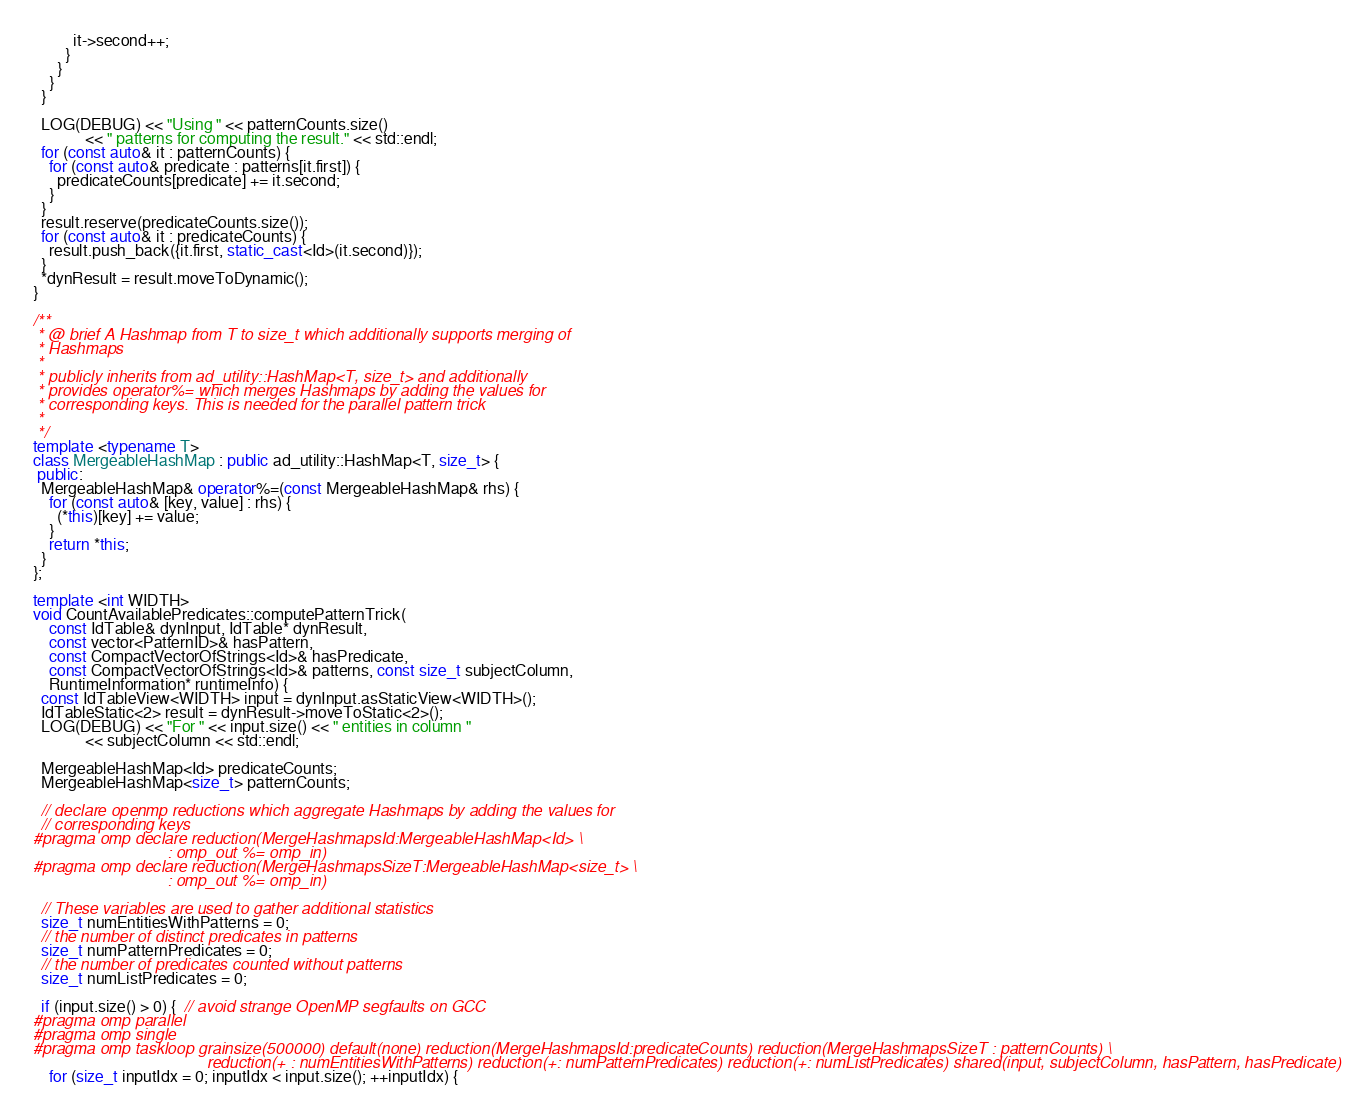Convert code to text. <code><loc_0><loc_0><loc_500><loc_500><_C++_>          it->second++;
        }
      }
    }
  }

  LOG(DEBUG) << "Using " << patternCounts.size()
             << " patterns for computing the result." << std::endl;
  for (const auto& it : patternCounts) {
    for (const auto& predicate : patterns[it.first]) {
      predicateCounts[predicate] += it.second;
    }
  }
  result.reserve(predicateCounts.size());
  for (const auto& it : predicateCounts) {
    result.push_back({it.first, static_cast<Id>(it.second)});
  }
  *dynResult = result.moveToDynamic();
}

/**
 * @ brief A Hashmap from T to size_t which additionally supports merging of
 * Hashmaps
 *
 * publicly inherits from ad_utility::HashMap<T, size_t> and additionally
 * provides operator%= which merges Hashmaps by adding the values for
 * corresponding keys. This is needed for the parallel pattern trick
 *
 */
template <typename T>
class MergeableHashMap : public ad_utility::HashMap<T, size_t> {
 public:
  MergeableHashMap& operator%=(const MergeableHashMap& rhs) {
    for (const auto& [key, value] : rhs) {
      (*this)[key] += value;
    }
    return *this;
  }
};

template <int WIDTH>
void CountAvailablePredicates::computePatternTrick(
    const IdTable& dynInput, IdTable* dynResult,
    const vector<PatternID>& hasPattern,
    const CompactVectorOfStrings<Id>& hasPredicate,
    const CompactVectorOfStrings<Id>& patterns, const size_t subjectColumn,
    RuntimeInformation* runtimeInfo) {
  const IdTableView<WIDTH> input = dynInput.asStaticView<WIDTH>();
  IdTableStatic<2> result = dynResult->moveToStatic<2>();
  LOG(DEBUG) << "For " << input.size() << " entities in column "
             << subjectColumn << std::endl;

  MergeableHashMap<Id> predicateCounts;
  MergeableHashMap<size_t> patternCounts;

  // declare openmp reductions which aggregate Hashmaps by adding the values for
  // corresponding keys
#pragma omp declare reduction(MergeHashmapsId:MergeableHashMap<Id> \
                              : omp_out %= omp_in)
#pragma omp declare reduction(MergeHashmapsSizeT:MergeableHashMap<size_t> \
                              : omp_out %= omp_in)

  // These variables are used to gather additional statistics
  size_t numEntitiesWithPatterns = 0;
  // the number of distinct predicates in patterns
  size_t numPatternPredicates = 0;
  // the number of predicates counted without patterns
  size_t numListPredicates = 0;

  if (input.size() > 0) {  // avoid strange OpenMP segfaults on GCC
#pragma omp parallel
#pragma omp single
#pragma omp taskloop grainsize(500000) default(none) reduction(MergeHashmapsId:predicateCounts) reduction(MergeHashmapsSizeT : patternCounts) \
                                       reduction(+ : numEntitiesWithPatterns) reduction(+: numPatternPredicates) reduction(+: numListPredicates) shared(input, subjectColumn, hasPattern, hasPredicate)
    for (size_t inputIdx = 0; inputIdx < input.size(); ++inputIdx) {</code> 